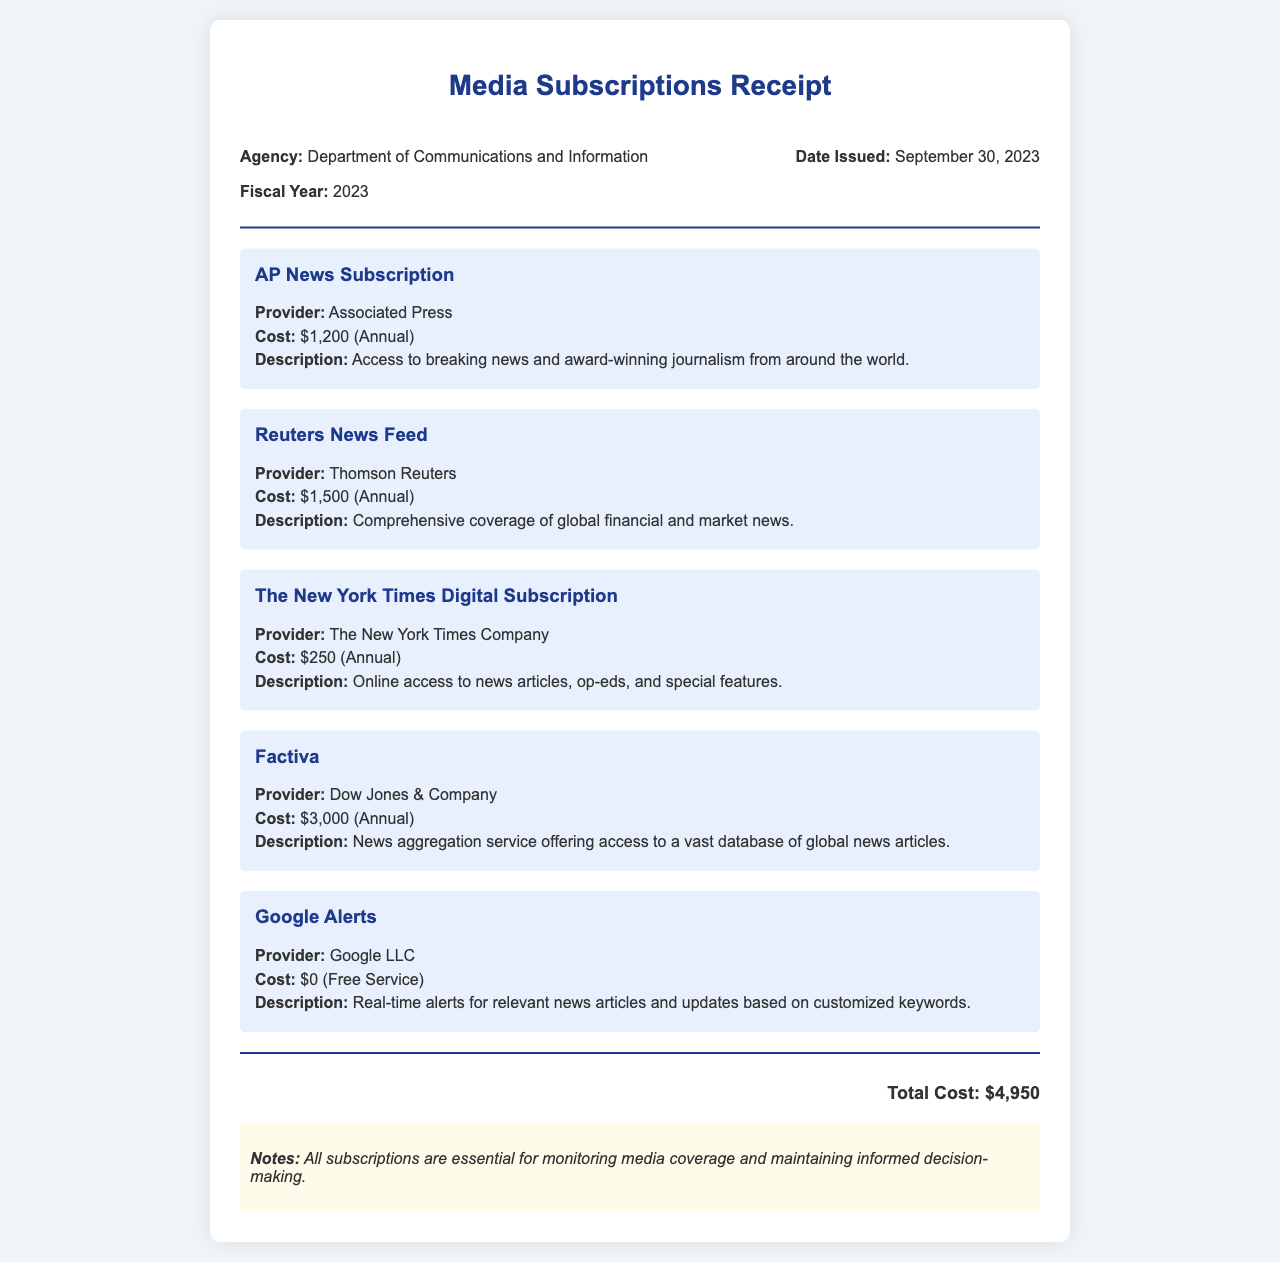What is the total cost of subscriptions? The total cost is provided at the bottom of the document, summing up all individual costs, which is $4,950.
Answer: $4,950 What is the provider of the AP News Subscription? The name of the provider is mentioned under the AP News Subscription section in the document.
Answer: Associated Press When was the receipt issued? The date issued is specified near the top of the document, providing the exact date of issuance.
Answer: September 30, 2023 What is the description of Google Alerts? The description for Google Alerts is detailed in the corresponding section, which explains its purpose.
Answer: Real-time alerts for relevant news articles and updates based on customized keywords How many subscriptions are listed in the document? The number of subscriptions can be counted from the list provided within the subscriptions section of the document.
Answer: Five What is the cost of The New York Times Digital Subscription? The cost is specifically mentioned in the section that describes The New York Times Digital Subscription.
Answer: $250 (Annual) Which subscription has the highest cost? By comparing the costs listed for each subscription, we identify which has the highest value clearly stipulated in the document.
Answer: Factiva What is the fiscal year mentioned in the receipt? The fiscal year is indicated at the top of the document as part of the header information.
Answer: 2023 